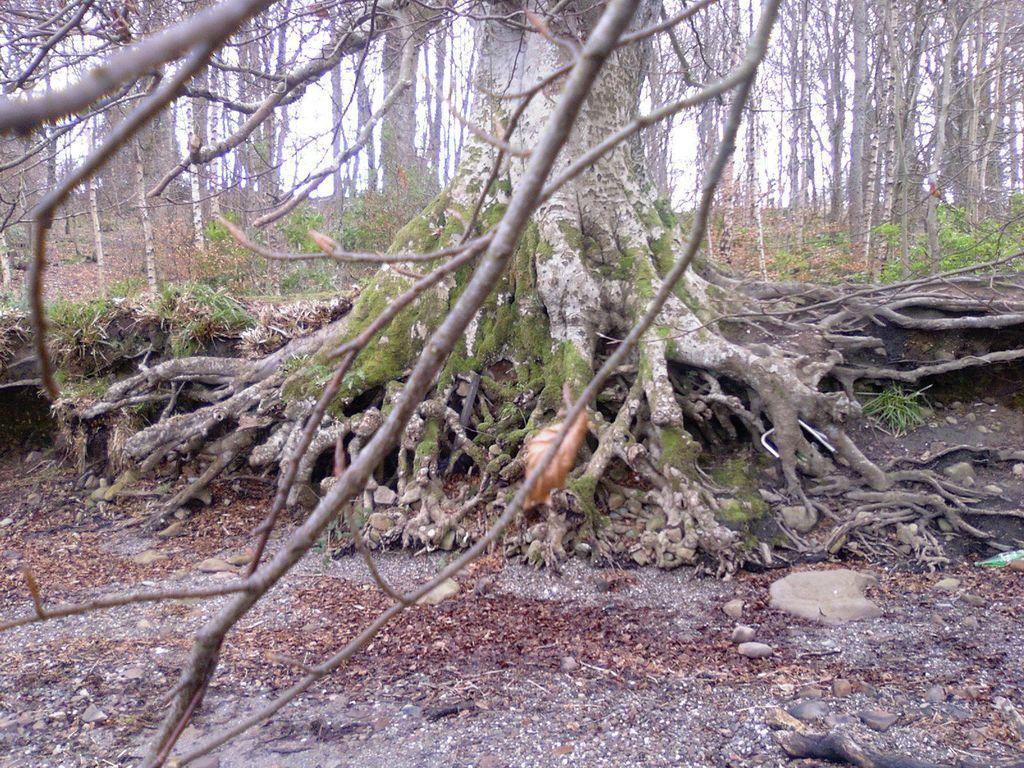Describe this image in one or two sentences. In this image, we can see some trees and plants. There are dry leaves on the ground. 